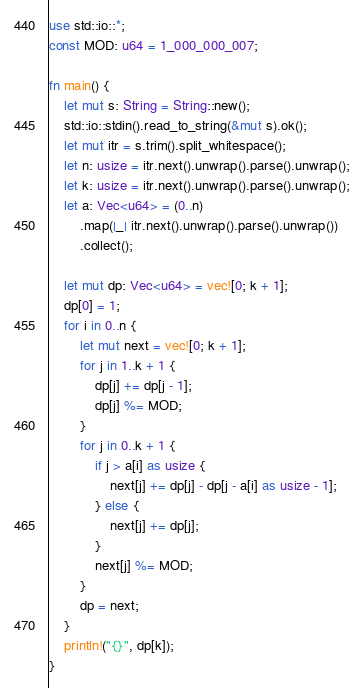Convert code to text. <code><loc_0><loc_0><loc_500><loc_500><_Rust_>use std::io::*;
const MOD: u64 = 1_000_000_007;

fn main() {
    let mut s: String = String::new();
    std::io::stdin().read_to_string(&mut s).ok();
    let mut itr = s.trim().split_whitespace();
    let n: usize = itr.next().unwrap().parse().unwrap();
    let k: usize = itr.next().unwrap().parse().unwrap();
    let a: Vec<u64> = (0..n)
        .map(|_| itr.next().unwrap().parse().unwrap())
        .collect();

    let mut dp: Vec<u64> = vec![0; k + 1];
    dp[0] = 1;
    for i in 0..n {
        let mut next = vec![0; k + 1];
        for j in 1..k + 1 {
            dp[j] += dp[j - 1];
            dp[j] %= MOD;
        }
        for j in 0..k + 1 {
            if j > a[i] as usize {
                next[j] += dp[j] - dp[j - a[i] as usize - 1];
            } else {
                next[j] += dp[j];
            }
            next[j] %= MOD;
        }
        dp = next;
    }
    println!("{}", dp[k]);
}
</code> 